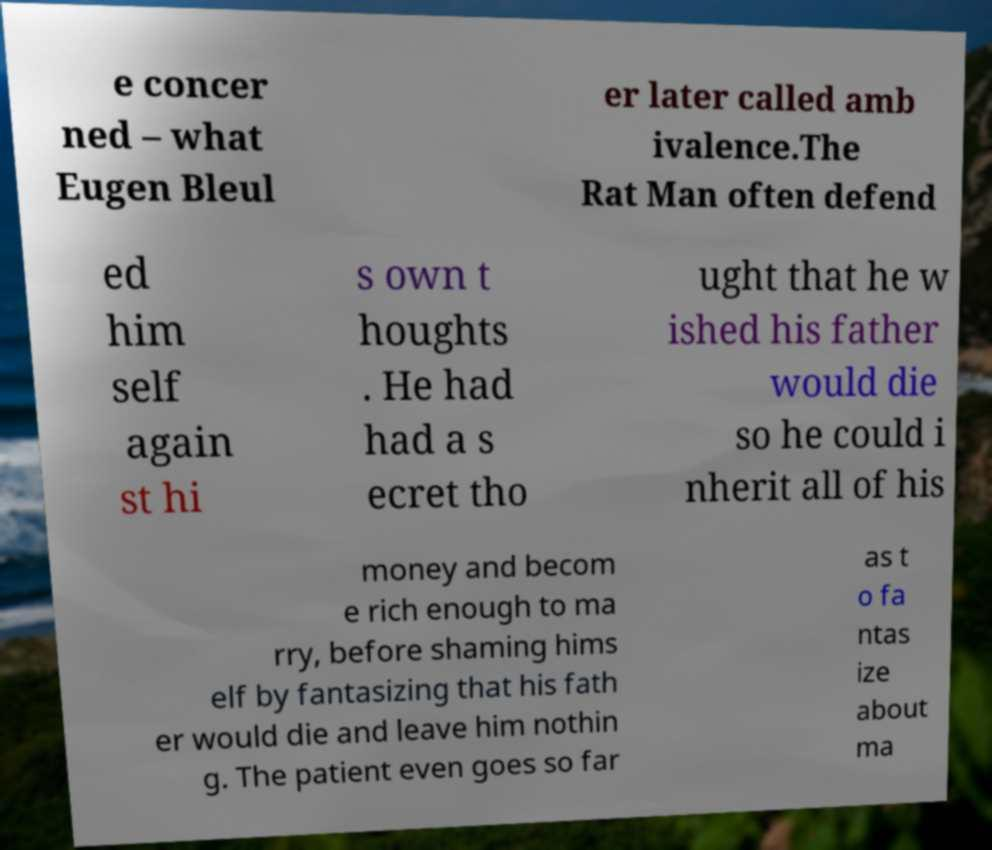Please identify and transcribe the text found in this image. e concer ned – what Eugen Bleul er later called amb ivalence.The Rat Man often defend ed him self again st hi s own t houghts . He had had a s ecret tho ught that he w ished his father would die so he could i nherit all of his money and becom e rich enough to ma rry, before shaming hims elf by fantasizing that his fath er would die and leave him nothin g. The patient even goes so far as t o fa ntas ize about ma 